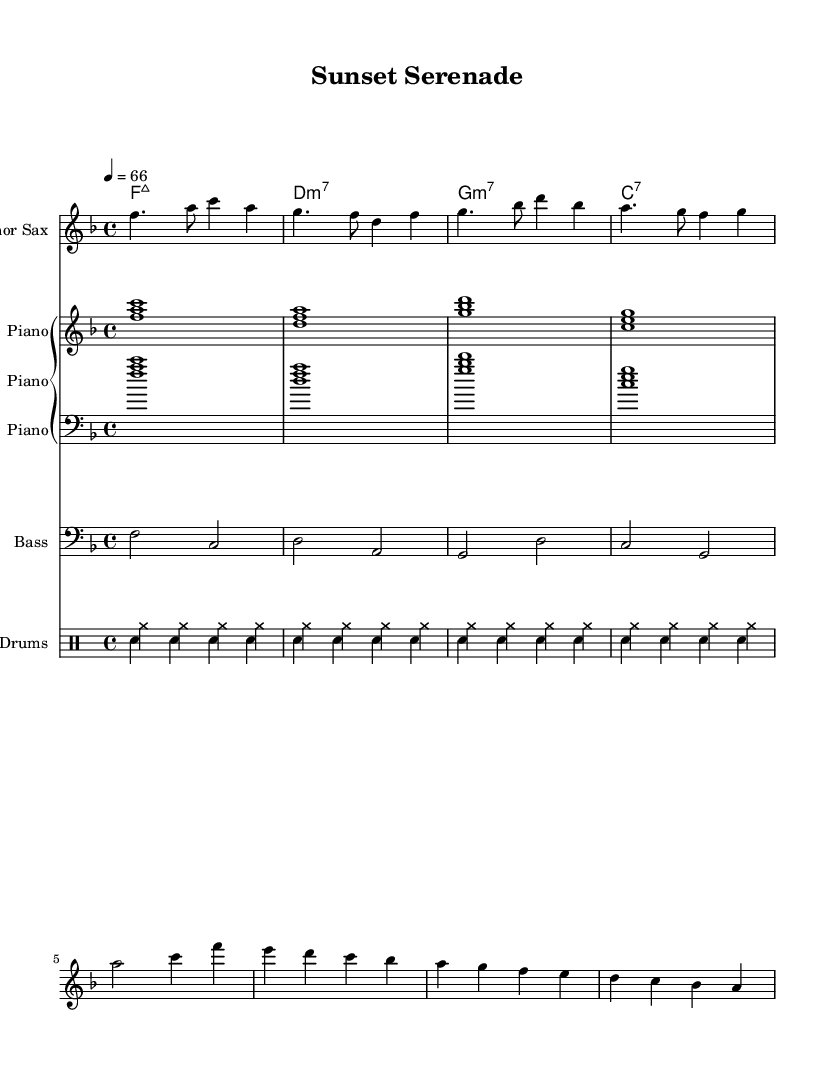what is the key signature of this music? The key signature is F major, indicated by one flat (B flat) at the beginning of the staff.
Answer: F major what is the time signature of this music? The time signature is 4/4, which means there are four beats in each measure and the quarter note gets one beat.
Answer: 4/4 what is the tempo marking of this piece? The tempo marking indicates 66 beats per minute, meaning the music should be played at a moderate pace.
Answer: 66 how many measures are in the saxophone part? Counting the individual measures in the saxophone staff, there are a total of 8 measures.
Answer: 8 which chord follows the D minor seventh chord? The sequence shows that after the D minor seventh chord, the next chord is G minor seventh.
Answer: G minor seventh what is the role of the bass in this piece? The bass part primarily supports the harmonic foundation by playing root notes and outlining the chords' progressions in a rhythmic manner.
Answer: Harmonic foundation how does the drum pattern contribute to the smooth jazz feel? The drum pattern features consistent cymbal hits paired with bass drum notes that create a laid-back rhythmic background, enhancing the smooth jazz atmosphere.
Answer: Laid-back rhythm 